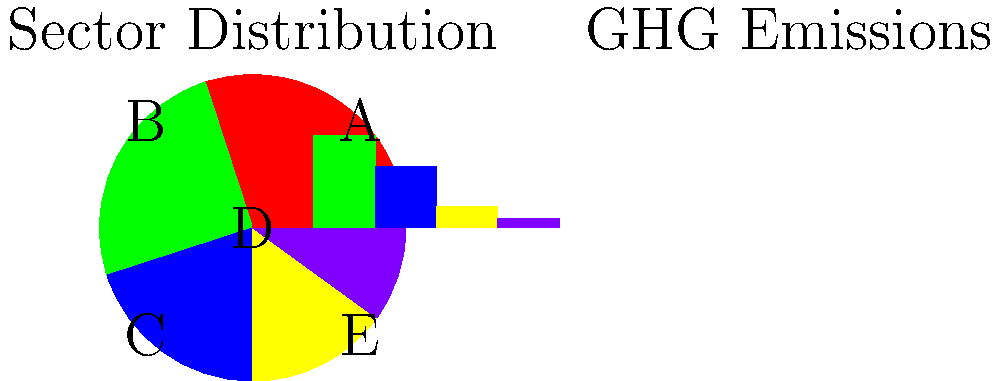Based on the pie chart showing sector distribution and the bar graph showing greenhouse gas (GHG) emissions in a Canadian industrial city, which sector (A, B, C, D, or E) is likely responsible for the highest percentage of GHG emissions while occupying a relatively smaller portion of the sector distribution? Justify your answer using the data presented in the graphs. To answer this question, we need to analyze both the pie chart (sector distribution) and the bar graph (GHG emissions) simultaneously:

1. First, let's rank the sectors by size in the pie chart:
   A > B > C > D > E

2. Now, let's rank the sectors by GHG emissions in the bar graph:
   1st bar > 2nd bar > 3rd bar > 4th bar > 5th bar

3. We're looking for a sector that has a relatively small slice in the pie chart but a large bar in the emissions graph.

4. Sector A has the largest slice and the tallest bar, so it's not our answer.

5. Sector E has the smallest slice and the shortest bar, so it's not our answer.

6. Sectors B and C have medium-sized slices and medium-height bars, so they're not likely candidates.

7. Sector D stands out because it has a relatively small slice in the pie chart (4th largest) but the second-tallest bar in the emissions graph.

This indicates that Sector D is responsible for a disproportionately high percentage of GHG emissions compared to its representation in the sector distribution.
Answer: Sector D 